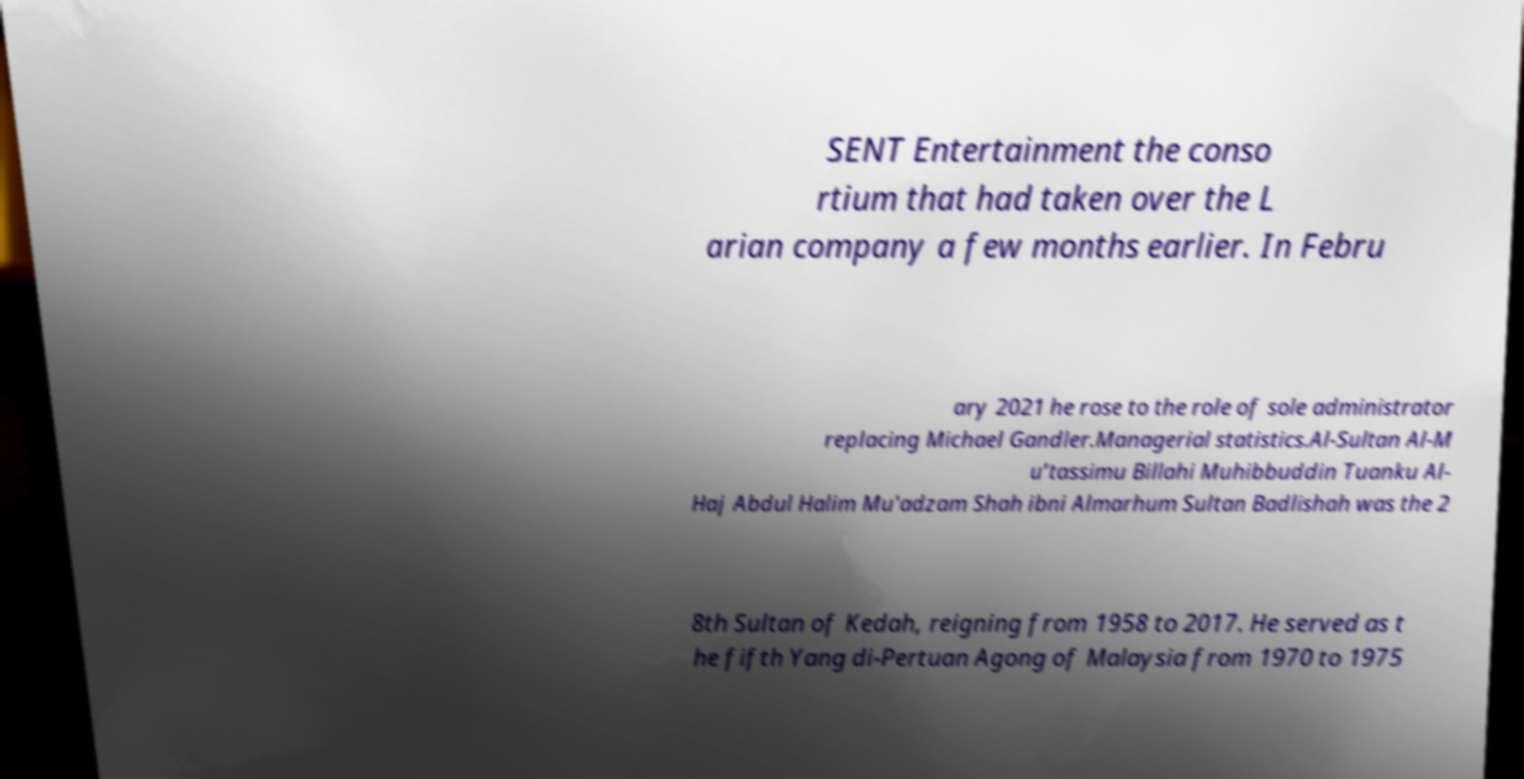I need the written content from this picture converted into text. Can you do that? SENT Entertainment the conso rtium that had taken over the L arian company a few months earlier. In Febru ary 2021 he rose to the role of sole administrator replacing Michael Gandler.Managerial statistics.Al-Sultan Al-M u’tassimu Billahi Muhibbuddin Tuanku Al- Haj Abdul Halim Mu'adzam Shah ibni Almarhum Sultan Badlishah was the 2 8th Sultan of Kedah, reigning from 1958 to 2017. He served as t he fifth Yang di-Pertuan Agong of Malaysia from 1970 to 1975 